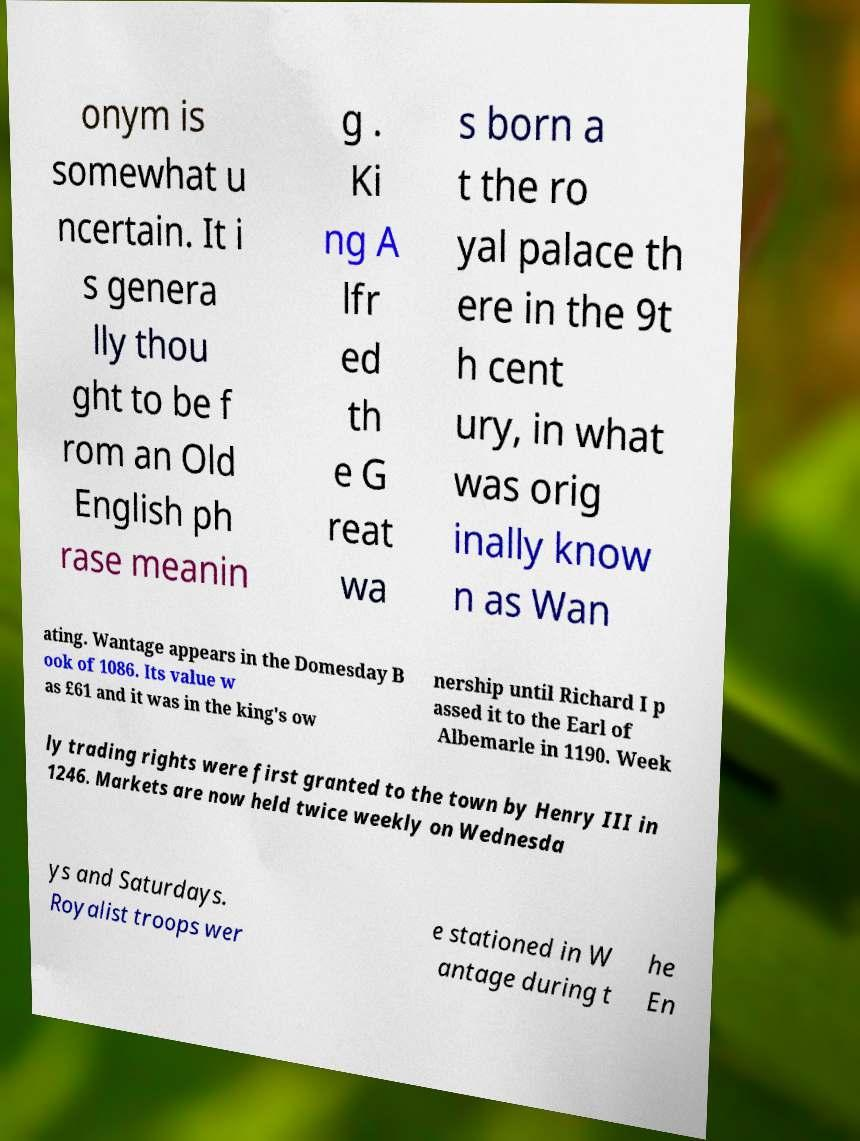Can you accurately transcribe the text from the provided image for me? onym is somewhat u ncertain. It i s genera lly thou ght to be f rom an Old English ph rase meanin g . Ki ng A lfr ed th e G reat wa s born a t the ro yal palace th ere in the 9t h cent ury, in what was orig inally know n as Wan ating. Wantage appears in the Domesday B ook of 1086. Its value w as £61 and it was in the king's ow nership until Richard I p assed it to the Earl of Albemarle in 1190. Week ly trading rights were first granted to the town by Henry III in 1246. Markets are now held twice weekly on Wednesda ys and Saturdays. Royalist troops wer e stationed in W antage during t he En 